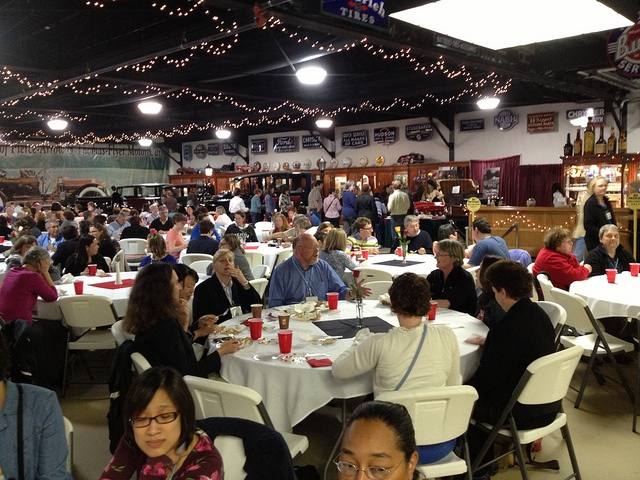Describe the objects in this image and their specific colors. I can see chair in black, gray, darkgray, and maroon tones, chair in black, gray, and tan tones, people in black, maroon, and gray tones, people in black, olive, maroon, and gray tones, and people in black, tan, and gray tones in this image. 